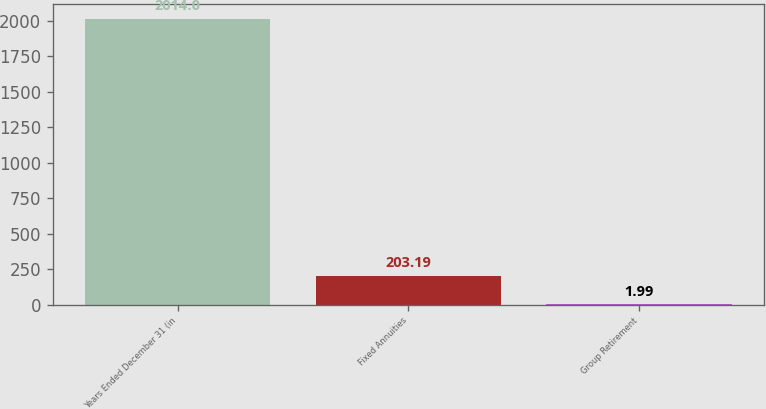Convert chart to OTSL. <chart><loc_0><loc_0><loc_500><loc_500><bar_chart><fcel>Years Ended December 31 (in<fcel>Fixed Annuities<fcel>Group Retirement<nl><fcel>2014<fcel>203.19<fcel>1.99<nl></chart> 